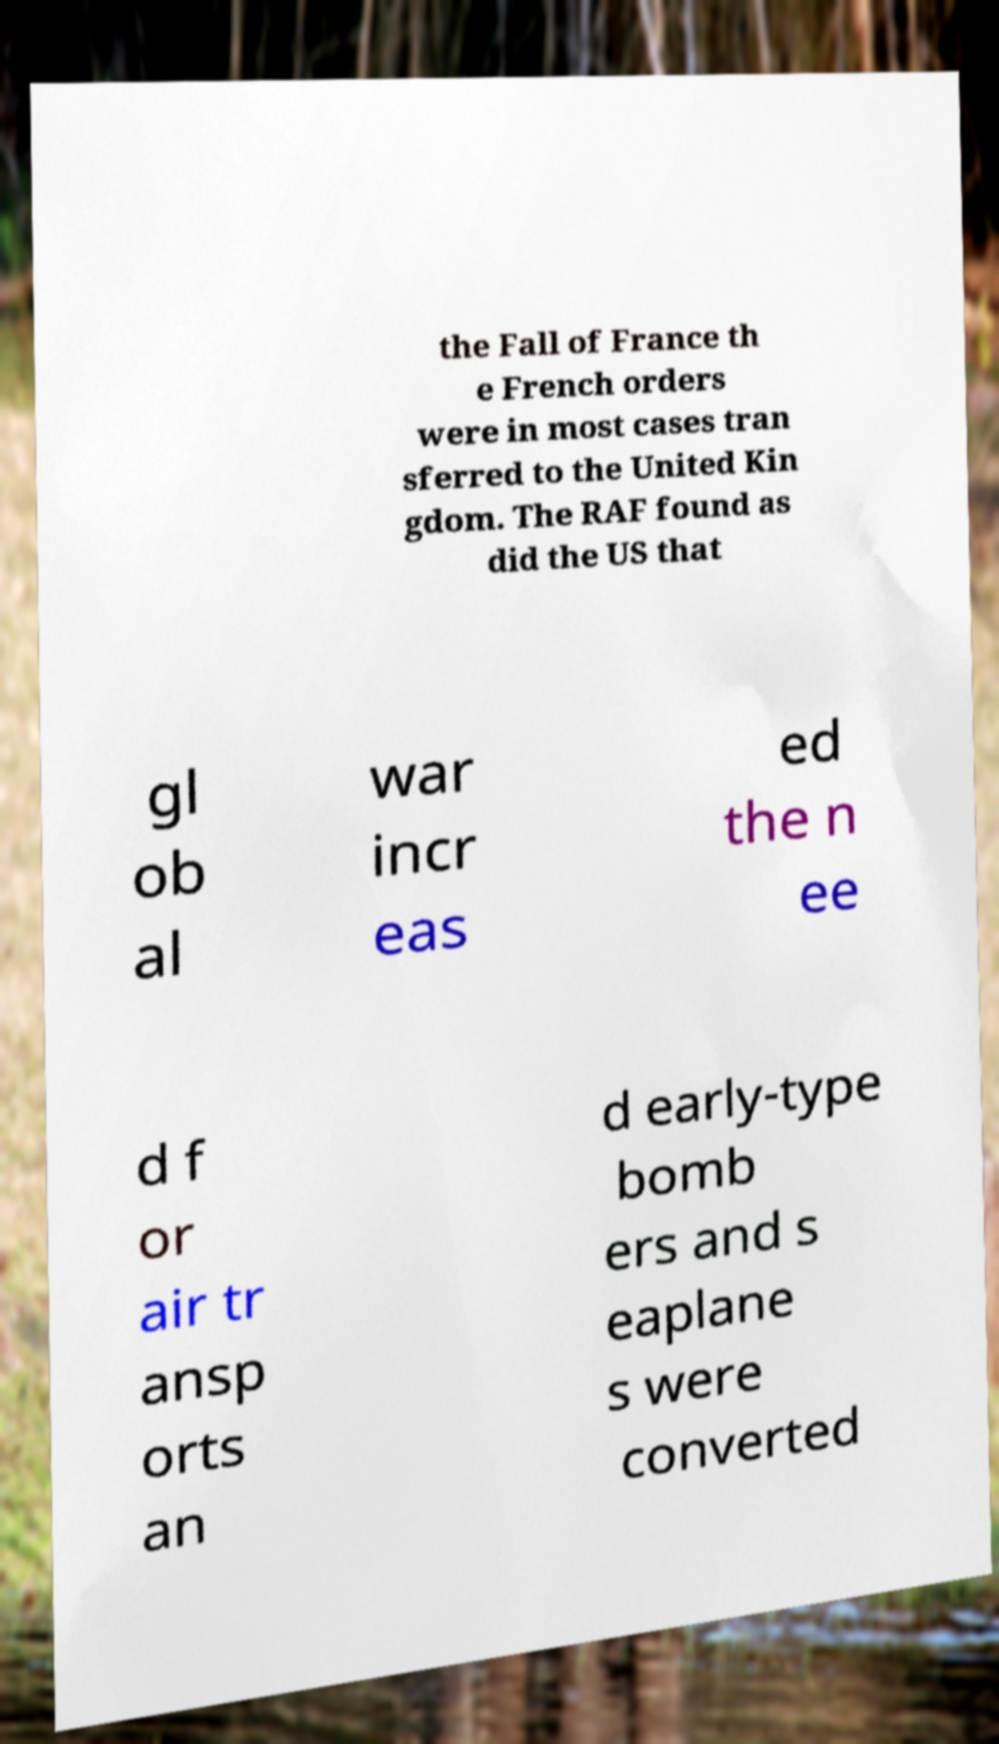There's text embedded in this image that I need extracted. Can you transcribe it verbatim? the Fall of France th e French orders were in most cases tran sferred to the United Kin gdom. The RAF found as did the US that gl ob al war incr eas ed the n ee d f or air tr ansp orts an d early-type bomb ers and s eaplane s were converted 